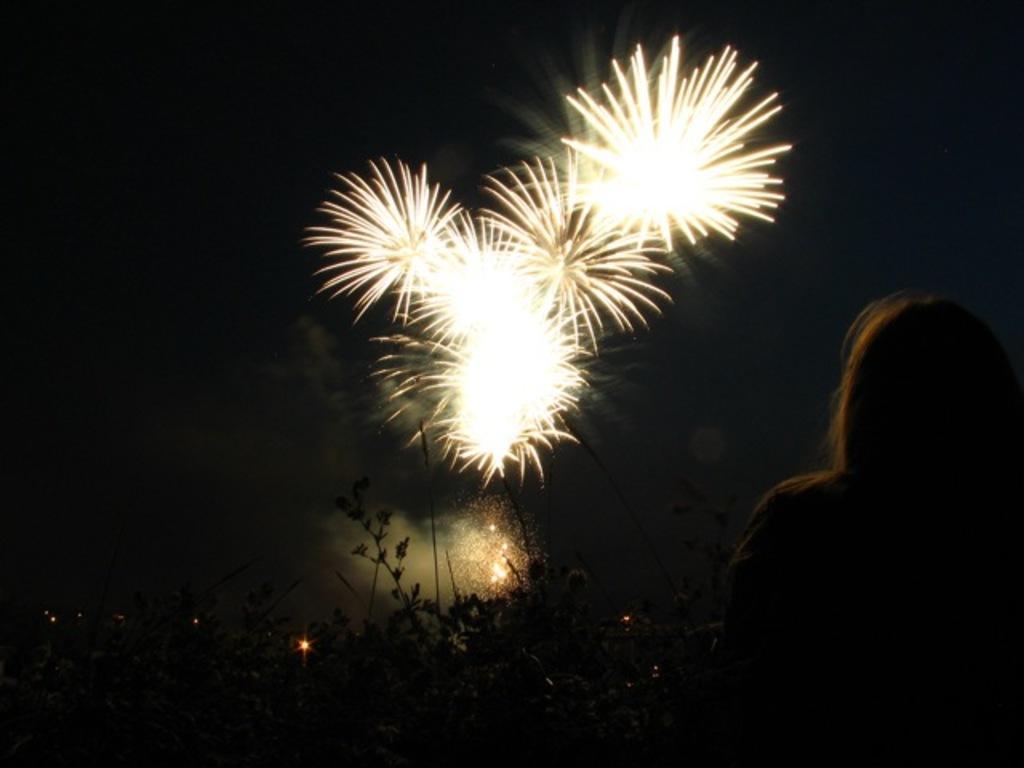Could you give a brief overview of what you see in this image? In the image there is a woman and there are some plants in front of her and in the sky there are beautiful firecrackers are being burned. 